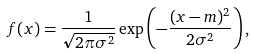<formula> <loc_0><loc_0><loc_500><loc_500>f ( x ) = \frac { 1 } { \sqrt { 2 \pi \sigma ^ { 2 } } } \exp \left ( - \frac { ( x - m ) ^ { 2 } } { 2 \sigma ^ { 2 } } \right ) ,</formula> 